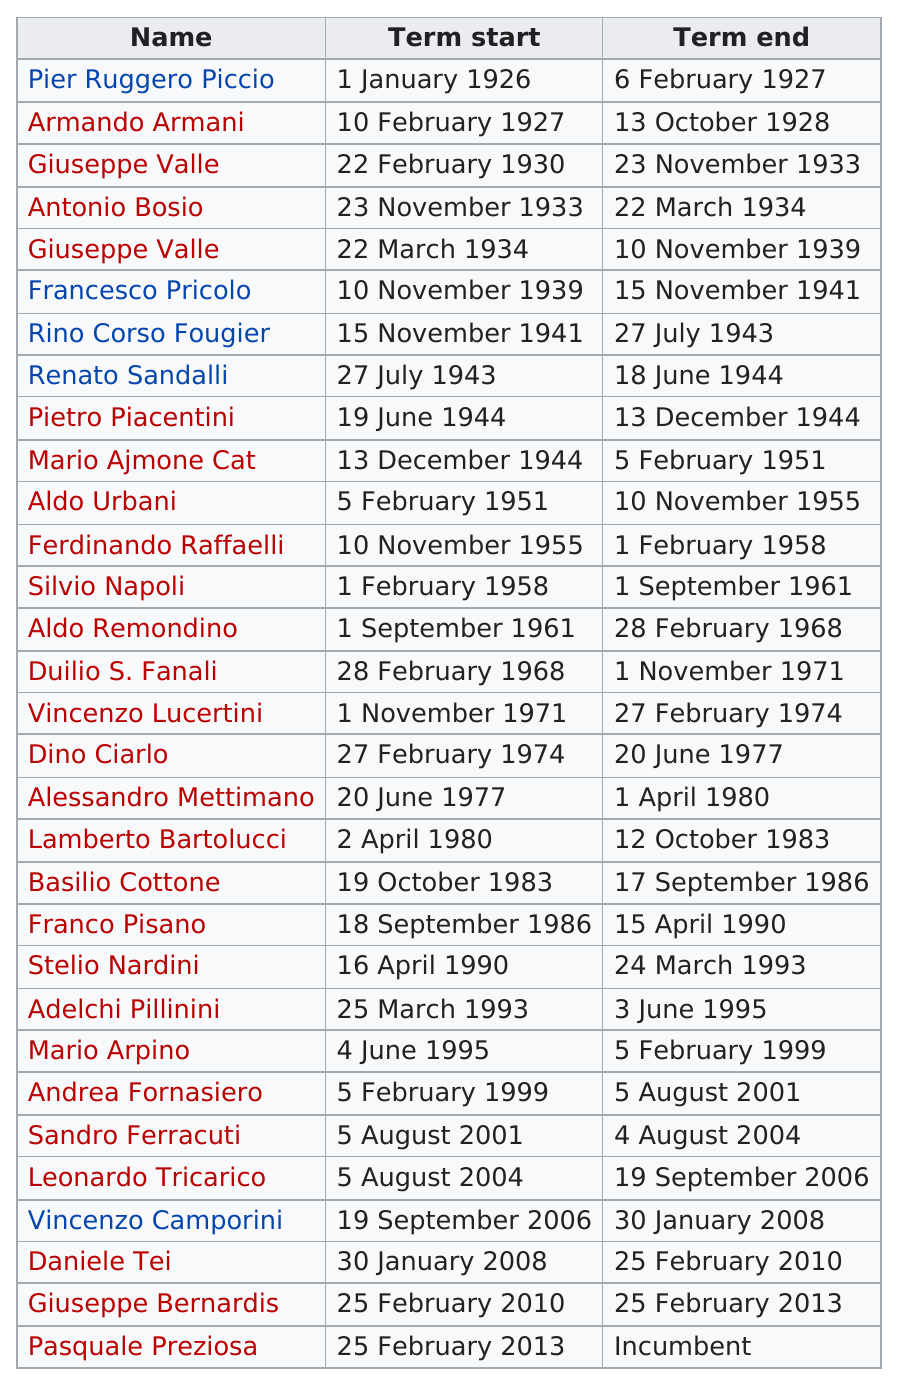Point out several critical features in this image. In the 1970s, a significant number of people had terms. The end date of Armando Armani's term was October 13, 1928. On January 1, 1926, Pier Ruggero Piccio's term began. 